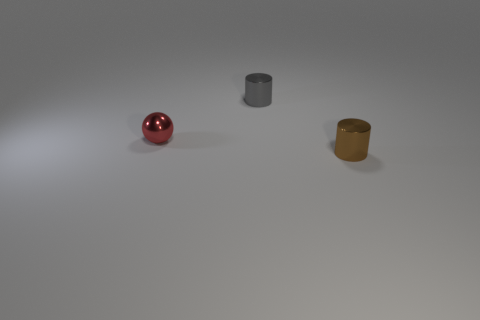How big is the ball?
Ensure brevity in your answer.  Small. Does the metal cylinder behind the brown metallic object have the same size as the small brown thing?
Offer a terse response. Yes. There is a metal thing to the left of the tiny cylinder behind the small metal cylinder in front of the tiny gray cylinder; what shape is it?
Provide a short and direct response. Sphere. How many objects are small metallic cylinders or cylinders in front of the gray thing?
Give a very brief answer. 2. What number of tiny things are on the left side of the cylinder left of the small cylinder to the right of the small gray metal cylinder?
Ensure brevity in your answer.  1. What number of red things are tiny objects or tiny cylinders?
Ensure brevity in your answer.  1. There is a tiny metal thing that is left of the tiny gray cylinder; what is its shape?
Make the answer very short. Sphere. There is a sphere that is the same size as the gray object; what color is it?
Offer a very short reply. Red. There is a small gray metallic thing; is it the same shape as the small shiny object that is in front of the small red thing?
Your answer should be compact. Yes. How many tiny things are gray metallic things or red balls?
Offer a very short reply. 2. 